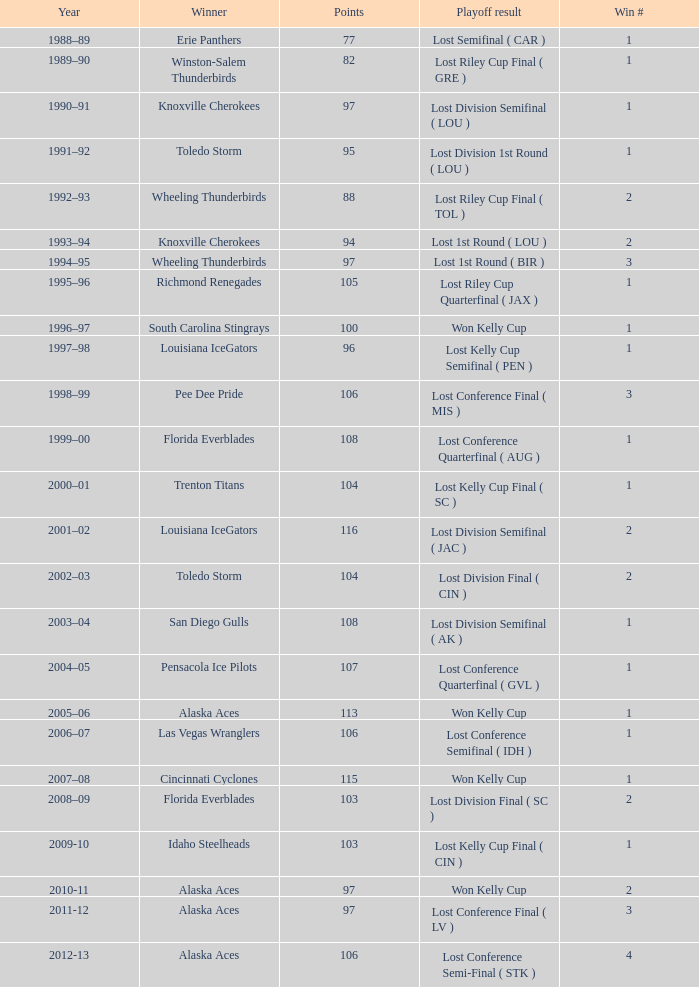What is Playoff Result, when Winner is "Alaska Aces", when Win # is greater than 1, when Points is less than 106, and when Year is "2011-12"? Lost Conference Final ( LV ). 